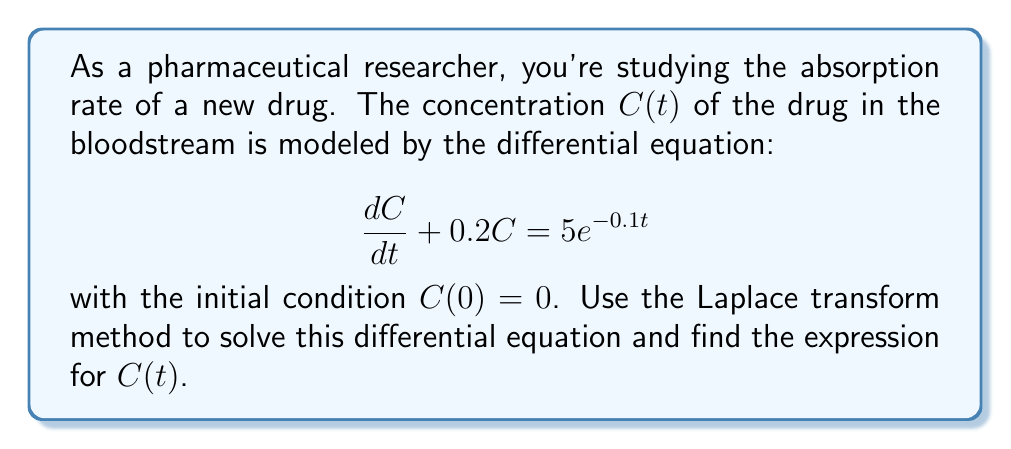Teach me how to tackle this problem. Let's solve this step-by-step using the Laplace transform method:

1) First, take the Laplace transform of both sides of the equation. Let $\mathcal{L}\{C(t)\} = X(s)$.

   $$\mathcal{L}\{\frac{dC}{dt} + 0.2C\} = \mathcal{L}\{5e^{-0.1t}\}$$

2) Using Laplace transform properties:

   $$sX(s) - C(0) + 0.2X(s) = \frac{5}{s+0.1}$$

3) Substitute the initial condition $C(0) = 0$:

   $$sX(s) + 0.2X(s) = \frac{5}{s+0.1}$$

4) Factor out $X(s)$:

   $$X(s)(s + 0.2) = \frac{5}{s+0.1}$$

5) Solve for $X(s)$:

   $$X(s) = \frac{5}{(s+0.2)(s+0.1)}$$

6) Use partial fraction decomposition:

   $$X(s) = \frac{A}{s+0.2} + \frac{B}{s+0.1}$$

   where $A$ and $B$ are constants to be determined.

7) Find $A$ and $B$:

   $$5 = A(s+0.1) + B(s+0.2)$$
   
   When $s = -0.2$: $5 = A(-0.1) + B(0)$, so $A = -50$
   When $s = -0.1$: $5 = A(0) + B(0.1)$, so $B = 50$

8) Therefore:

   $$X(s) = \frac{-50}{s+0.2} + \frac{50}{s+0.1}$$

9) Take the inverse Laplace transform:

   $$C(t) = -50e^{-0.2t} + 50e^{-0.1t}$$

10) Simplify:

    $$C(t) = 50(e^{-0.1t} - e^{-0.2t})$$
Answer: $C(t) = 50(e^{-0.1t} - e^{-0.2t})$ 